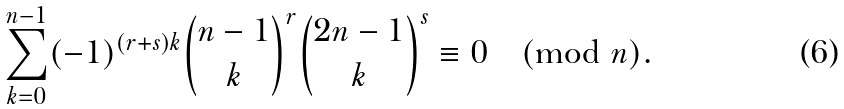Convert formula to latex. <formula><loc_0><loc_0><loc_500><loc_500>\sum _ { k = 0 } ^ { n - 1 } ( - 1 ) ^ { ( r + s ) k } { n - 1 \choose k } ^ { r } { 2 n - 1 \choose k } ^ { s } & \equiv 0 \pmod { n } .</formula> 